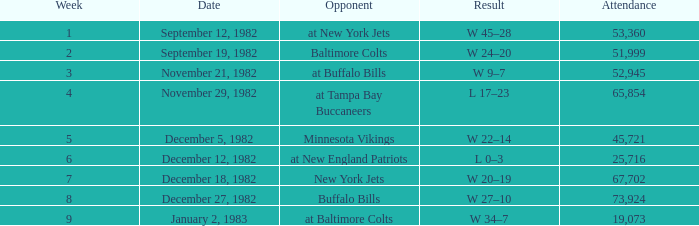What is the result of the game with an attendance greater than 67,702? W 27–10. 